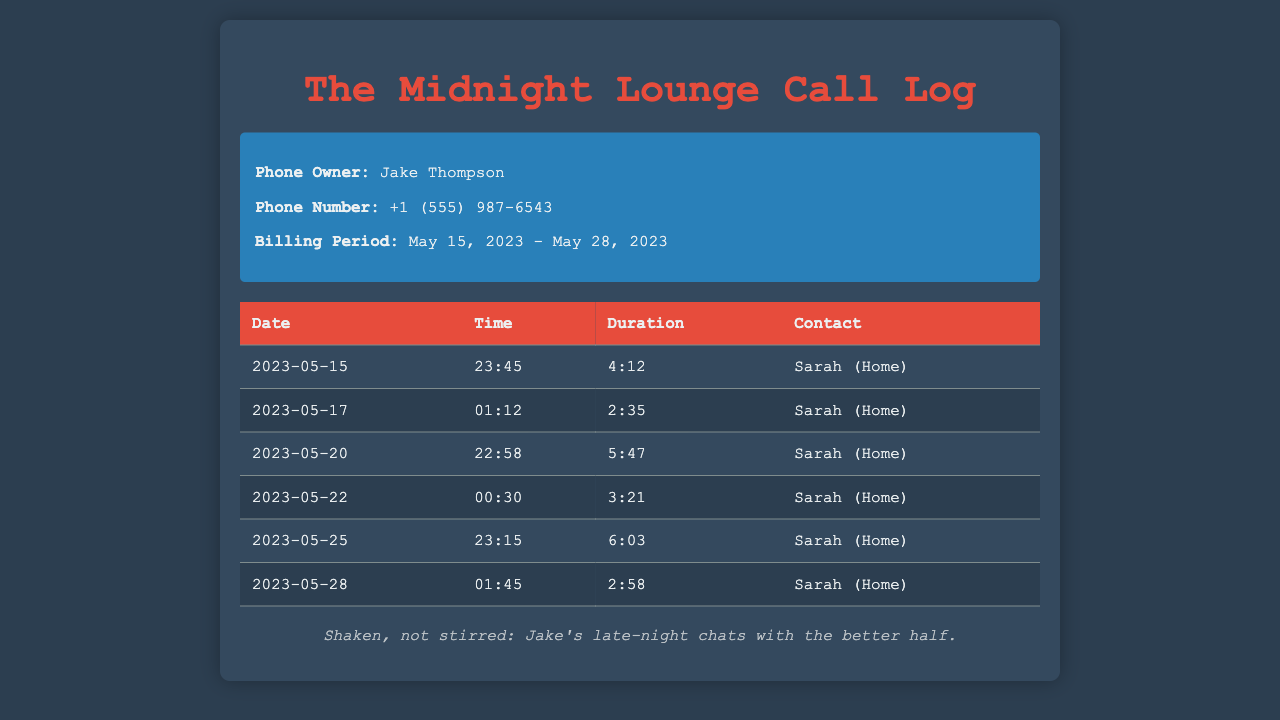what is the phone owner's name? The phone owner's name is listed prominently at the top of the document as Jake Thompson.
Answer: Jake Thompson how many calls were made to Sarah during this period? The document lists six calls made to Sarah, all marked as "Home."
Answer: 6 what was the longest call duration? To find the longest duration, we compare each call's duration, which shows the longest is 6:03 on May 25.
Answer: 6:03 which date had the earliest call? The date of the earliest call found in the log is May 15, 2023, at 23:45.
Answer: 2023-05-15 how many calls were made after midnight? By checking the times, there are three calls after midnight: May 22, May 25, and May 28.
Answer: 3 what was the total duration of calls to Sarah? To find the total, we need to add all call durations: 4:12 + 2:35 + 5:47 + 3:21 + 6:03 + 2:58, which equals 24:56.
Answer: 24:56 what time was the second call made? The second call is recorded at 01:12 on May 17, 2023.
Answer: 01:12 what unique contact name appears in the call log? The unique contact name listed in the call log is Sarah.
Answer: Sarah 